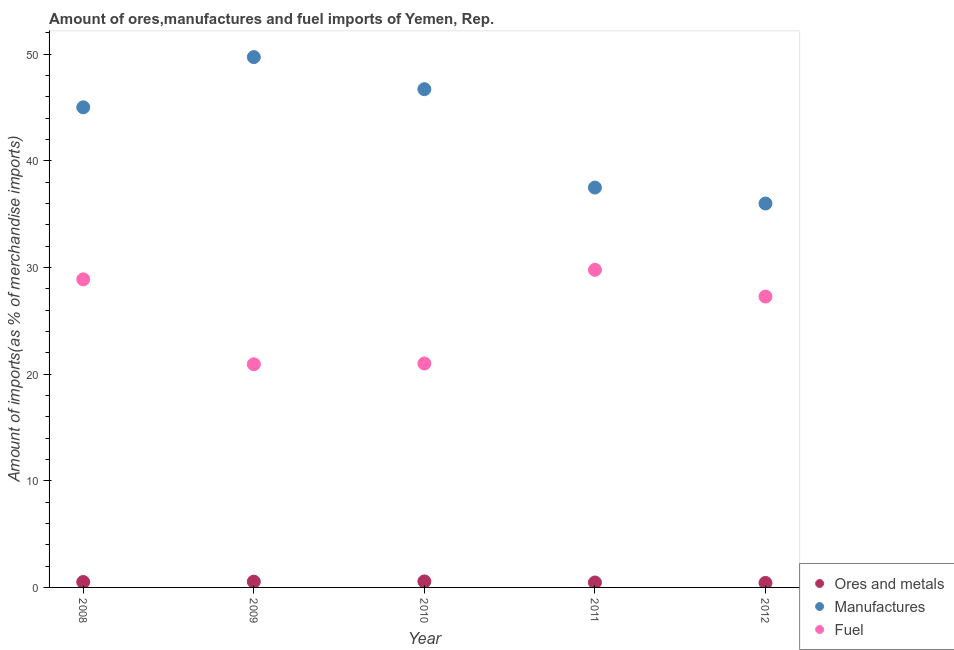Is the number of dotlines equal to the number of legend labels?
Offer a terse response. Yes. What is the percentage of fuel imports in 2008?
Ensure brevity in your answer.  28.89. Across all years, what is the maximum percentage of fuel imports?
Make the answer very short. 29.79. Across all years, what is the minimum percentage of fuel imports?
Offer a terse response. 20.93. In which year was the percentage of ores and metals imports maximum?
Your response must be concise. 2010. In which year was the percentage of manufactures imports minimum?
Your answer should be compact. 2012. What is the total percentage of manufactures imports in the graph?
Offer a very short reply. 214.99. What is the difference between the percentage of fuel imports in 2008 and that in 2010?
Your response must be concise. 7.89. What is the difference between the percentage of fuel imports in 2011 and the percentage of ores and metals imports in 2012?
Your answer should be compact. 29.36. What is the average percentage of manufactures imports per year?
Provide a succinct answer. 43. In the year 2010, what is the difference between the percentage of fuel imports and percentage of manufactures imports?
Provide a succinct answer. -25.73. What is the ratio of the percentage of manufactures imports in 2010 to that in 2011?
Offer a terse response. 1.25. Is the difference between the percentage of fuel imports in 2008 and 2012 greater than the difference between the percentage of ores and metals imports in 2008 and 2012?
Keep it short and to the point. Yes. What is the difference between the highest and the second highest percentage of manufactures imports?
Your response must be concise. 3.01. What is the difference between the highest and the lowest percentage of ores and metals imports?
Your answer should be compact. 0.14. In how many years, is the percentage of manufactures imports greater than the average percentage of manufactures imports taken over all years?
Your answer should be compact. 3. Is the sum of the percentage of ores and metals imports in 2010 and 2012 greater than the maximum percentage of fuel imports across all years?
Give a very brief answer. No. Is the percentage of manufactures imports strictly less than the percentage of ores and metals imports over the years?
Provide a short and direct response. No. How many dotlines are there?
Offer a very short reply. 3. What is the difference between two consecutive major ticks on the Y-axis?
Your answer should be very brief. 10. Does the graph contain any zero values?
Your answer should be very brief. No. Does the graph contain grids?
Offer a terse response. No. How are the legend labels stacked?
Offer a very short reply. Vertical. What is the title of the graph?
Offer a very short reply. Amount of ores,manufactures and fuel imports of Yemen, Rep. What is the label or title of the X-axis?
Keep it short and to the point. Year. What is the label or title of the Y-axis?
Provide a succinct answer. Amount of imports(as % of merchandise imports). What is the Amount of imports(as % of merchandise imports) of Ores and metals in 2008?
Provide a short and direct response. 0.51. What is the Amount of imports(as % of merchandise imports) of Manufactures in 2008?
Give a very brief answer. 45.03. What is the Amount of imports(as % of merchandise imports) in Fuel in 2008?
Offer a very short reply. 28.89. What is the Amount of imports(as % of merchandise imports) of Ores and metals in 2009?
Ensure brevity in your answer.  0.54. What is the Amount of imports(as % of merchandise imports) of Manufactures in 2009?
Provide a succinct answer. 49.73. What is the Amount of imports(as % of merchandise imports) of Fuel in 2009?
Make the answer very short. 20.93. What is the Amount of imports(as % of merchandise imports) of Ores and metals in 2010?
Give a very brief answer. 0.56. What is the Amount of imports(as % of merchandise imports) in Manufactures in 2010?
Make the answer very short. 46.73. What is the Amount of imports(as % of merchandise imports) in Fuel in 2010?
Provide a succinct answer. 21. What is the Amount of imports(as % of merchandise imports) of Ores and metals in 2011?
Make the answer very short. 0.46. What is the Amount of imports(as % of merchandise imports) in Manufactures in 2011?
Provide a short and direct response. 37.5. What is the Amount of imports(as % of merchandise imports) in Fuel in 2011?
Offer a very short reply. 29.79. What is the Amount of imports(as % of merchandise imports) of Ores and metals in 2012?
Your answer should be very brief. 0.42. What is the Amount of imports(as % of merchandise imports) of Manufactures in 2012?
Provide a succinct answer. 36. What is the Amount of imports(as % of merchandise imports) in Fuel in 2012?
Your answer should be compact. 27.28. Across all years, what is the maximum Amount of imports(as % of merchandise imports) in Ores and metals?
Offer a very short reply. 0.56. Across all years, what is the maximum Amount of imports(as % of merchandise imports) in Manufactures?
Offer a very short reply. 49.73. Across all years, what is the maximum Amount of imports(as % of merchandise imports) of Fuel?
Give a very brief answer. 29.79. Across all years, what is the minimum Amount of imports(as % of merchandise imports) of Ores and metals?
Ensure brevity in your answer.  0.42. Across all years, what is the minimum Amount of imports(as % of merchandise imports) of Manufactures?
Your response must be concise. 36. Across all years, what is the minimum Amount of imports(as % of merchandise imports) in Fuel?
Offer a very short reply. 20.93. What is the total Amount of imports(as % of merchandise imports) of Ores and metals in the graph?
Offer a very short reply. 2.5. What is the total Amount of imports(as % of merchandise imports) of Manufactures in the graph?
Make the answer very short. 214.99. What is the total Amount of imports(as % of merchandise imports) in Fuel in the graph?
Your answer should be compact. 127.88. What is the difference between the Amount of imports(as % of merchandise imports) in Ores and metals in 2008 and that in 2009?
Keep it short and to the point. -0.04. What is the difference between the Amount of imports(as % of merchandise imports) in Manufactures in 2008 and that in 2009?
Your answer should be very brief. -4.71. What is the difference between the Amount of imports(as % of merchandise imports) in Fuel in 2008 and that in 2009?
Give a very brief answer. 7.96. What is the difference between the Amount of imports(as % of merchandise imports) in Ores and metals in 2008 and that in 2010?
Ensure brevity in your answer.  -0.06. What is the difference between the Amount of imports(as % of merchandise imports) in Manufactures in 2008 and that in 2010?
Ensure brevity in your answer.  -1.7. What is the difference between the Amount of imports(as % of merchandise imports) of Fuel in 2008 and that in 2010?
Provide a succinct answer. 7.89. What is the difference between the Amount of imports(as % of merchandise imports) in Ores and metals in 2008 and that in 2011?
Offer a very short reply. 0.04. What is the difference between the Amount of imports(as % of merchandise imports) in Manufactures in 2008 and that in 2011?
Offer a very short reply. 7.53. What is the difference between the Amount of imports(as % of merchandise imports) in Fuel in 2008 and that in 2011?
Make the answer very short. -0.89. What is the difference between the Amount of imports(as % of merchandise imports) of Ores and metals in 2008 and that in 2012?
Ensure brevity in your answer.  0.08. What is the difference between the Amount of imports(as % of merchandise imports) of Manufactures in 2008 and that in 2012?
Make the answer very short. 9.02. What is the difference between the Amount of imports(as % of merchandise imports) of Fuel in 2008 and that in 2012?
Provide a short and direct response. 1.61. What is the difference between the Amount of imports(as % of merchandise imports) of Ores and metals in 2009 and that in 2010?
Offer a very short reply. -0.02. What is the difference between the Amount of imports(as % of merchandise imports) in Manufactures in 2009 and that in 2010?
Give a very brief answer. 3.01. What is the difference between the Amount of imports(as % of merchandise imports) in Fuel in 2009 and that in 2010?
Keep it short and to the point. -0.07. What is the difference between the Amount of imports(as % of merchandise imports) in Ores and metals in 2009 and that in 2011?
Offer a terse response. 0.08. What is the difference between the Amount of imports(as % of merchandise imports) in Manufactures in 2009 and that in 2011?
Keep it short and to the point. 12.23. What is the difference between the Amount of imports(as % of merchandise imports) in Fuel in 2009 and that in 2011?
Keep it short and to the point. -8.86. What is the difference between the Amount of imports(as % of merchandise imports) of Ores and metals in 2009 and that in 2012?
Offer a terse response. 0.12. What is the difference between the Amount of imports(as % of merchandise imports) of Manufactures in 2009 and that in 2012?
Provide a succinct answer. 13.73. What is the difference between the Amount of imports(as % of merchandise imports) in Fuel in 2009 and that in 2012?
Your answer should be compact. -6.35. What is the difference between the Amount of imports(as % of merchandise imports) in Ores and metals in 2010 and that in 2011?
Offer a very short reply. 0.1. What is the difference between the Amount of imports(as % of merchandise imports) of Manufactures in 2010 and that in 2011?
Your answer should be very brief. 9.23. What is the difference between the Amount of imports(as % of merchandise imports) in Fuel in 2010 and that in 2011?
Ensure brevity in your answer.  -8.79. What is the difference between the Amount of imports(as % of merchandise imports) in Ores and metals in 2010 and that in 2012?
Your response must be concise. 0.14. What is the difference between the Amount of imports(as % of merchandise imports) of Manufactures in 2010 and that in 2012?
Your response must be concise. 10.72. What is the difference between the Amount of imports(as % of merchandise imports) of Fuel in 2010 and that in 2012?
Keep it short and to the point. -6.28. What is the difference between the Amount of imports(as % of merchandise imports) in Ores and metals in 2011 and that in 2012?
Your answer should be compact. 0.04. What is the difference between the Amount of imports(as % of merchandise imports) in Manufactures in 2011 and that in 2012?
Your answer should be compact. 1.5. What is the difference between the Amount of imports(as % of merchandise imports) of Fuel in 2011 and that in 2012?
Provide a short and direct response. 2.51. What is the difference between the Amount of imports(as % of merchandise imports) in Ores and metals in 2008 and the Amount of imports(as % of merchandise imports) in Manufactures in 2009?
Offer a very short reply. -49.23. What is the difference between the Amount of imports(as % of merchandise imports) in Ores and metals in 2008 and the Amount of imports(as % of merchandise imports) in Fuel in 2009?
Ensure brevity in your answer.  -20.42. What is the difference between the Amount of imports(as % of merchandise imports) of Manufactures in 2008 and the Amount of imports(as % of merchandise imports) of Fuel in 2009?
Provide a succinct answer. 24.1. What is the difference between the Amount of imports(as % of merchandise imports) in Ores and metals in 2008 and the Amount of imports(as % of merchandise imports) in Manufactures in 2010?
Offer a terse response. -46.22. What is the difference between the Amount of imports(as % of merchandise imports) of Ores and metals in 2008 and the Amount of imports(as % of merchandise imports) of Fuel in 2010?
Your answer should be compact. -20.49. What is the difference between the Amount of imports(as % of merchandise imports) in Manufactures in 2008 and the Amount of imports(as % of merchandise imports) in Fuel in 2010?
Offer a very short reply. 24.02. What is the difference between the Amount of imports(as % of merchandise imports) of Ores and metals in 2008 and the Amount of imports(as % of merchandise imports) of Manufactures in 2011?
Ensure brevity in your answer.  -36.99. What is the difference between the Amount of imports(as % of merchandise imports) in Ores and metals in 2008 and the Amount of imports(as % of merchandise imports) in Fuel in 2011?
Offer a terse response. -29.28. What is the difference between the Amount of imports(as % of merchandise imports) in Manufactures in 2008 and the Amount of imports(as % of merchandise imports) in Fuel in 2011?
Your answer should be compact. 15.24. What is the difference between the Amount of imports(as % of merchandise imports) of Ores and metals in 2008 and the Amount of imports(as % of merchandise imports) of Manufactures in 2012?
Provide a short and direct response. -35.5. What is the difference between the Amount of imports(as % of merchandise imports) in Ores and metals in 2008 and the Amount of imports(as % of merchandise imports) in Fuel in 2012?
Your response must be concise. -26.77. What is the difference between the Amount of imports(as % of merchandise imports) in Manufactures in 2008 and the Amount of imports(as % of merchandise imports) in Fuel in 2012?
Your answer should be compact. 17.75. What is the difference between the Amount of imports(as % of merchandise imports) in Ores and metals in 2009 and the Amount of imports(as % of merchandise imports) in Manufactures in 2010?
Offer a terse response. -46.18. What is the difference between the Amount of imports(as % of merchandise imports) in Ores and metals in 2009 and the Amount of imports(as % of merchandise imports) in Fuel in 2010?
Keep it short and to the point. -20.46. What is the difference between the Amount of imports(as % of merchandise imports) of Manufactures in 2009 and the Amount of imports(as % of merchandise imports) of Fuel in 2010?
Offer a very short reply. 28.73. What is the difference between the Amount of imports(as % of merchandise imports) of Ores and metals in 2009 and the Amount of imports(as % of merchandise imports) of Manufactures in 2011?
Your answer should be very brief. -36.96. What is the difference between the Amount of imports(as % of merchandise imports) in Ores and metals in 2009 and the Amount of imports(as % of merchandise imports) in Fuel in 2011?
Provide a succinct answer. -29.24. What is the difference between the Amount of imports(as % of merchandise imports) in Manufactures in 2009 and the Amount of imports(as % of merchandise imports) in Fuel in 2011?
Provide a succinct answer. 19.95. What is the difference between the Amount of imports(as % of merchandise imports) of Ores and metals in 2009 and the Amount of imports(as % of merchandise imports) of Manufactures in 2012?
Ensure brevity in your answer.  -35.46. What is the difference between the Amount of imports(as % of merchandise imports) of Ores and metals in 2009 and the Amount of imports(as % of merchandise imports) of Fuel in 2012?
Ensure brevity in your answer.  -26.73. What is the difference between the Amount of imports(as % of merchandise imports) in Manufactures in 2009 and the Amount of imports(as % of merchandise imports) in Fuel in 2012?
Provide a succinct answer. 22.46. What is the difference between the Amount of imports(as % of merchandise imports) of Ores and metals in 2010 and the Amount of imports(as % of merchandise imports) of Manufactures in 2011?
Ensure brevity in your answer.  -36.94. What is the difference between the Amount of imports(as % of merchandise imports) of Ores and metals in 2010 and the Amount of imports(as % of merchandise imports) of Fuel in 2011?
Ensure brevity in your answer.  -29.22. What is the difference between the Amount of imports(as % of merchandise imports) in Manufactures in 2010 and the Amount of imports(as % of merchandise imports) in Fuel in 2011?
Provide a succinct answer. 16.94. What is the difference between the Amount of imports(as % of merchandise imports) in Ores and metals in 2010 and the Amount of imports(as % of merchandise imports) in Manufactures in 2012?
Make the answer very short. -35.44. What is the difference between the Amount of imports(as % of merchandise imports) in Ores and metals in 2010 and the Amount of imports(as % of merchandise imports) in Fuel in 2012?
Offer a terse response. -26.71. What is the difference between the Amount of imports(as % of merchandise imports) in Manufactures in 2010 and the Amount of imports(as % of merchandise imports) in Fuel in 2012?
Provide a short and direct response. 19.45. What is the difference between the Amount of imports(as % of merchandise imports) of Ores and metals in 2011 and the Amount of imports(as % of merchandise imports) of Manufactures in 2012?
Your answer should be compact. -35.54. What is the difference between the Amount of imports(as % of merchandise imports) of Ores and metals in 2011 and the Amount of imports(as % of merchandise imports) of Fuel in 2012?
Keep it short and to the point. -26.81. What is the difference between the Amount of imports(as % of merchandise imports) in Manufactures in 2011 and the Amount of imports(as % of merchandise imports) in Fuel in 2012?
Your answer should be very brief. 10.22. What is the average Amount of imports(as % of merchandise imports) in Ores and metals per year?
Provide a short and direct response. 0.5. What is the average Amount of imports(as % of merchandise imports) in Manufactures per year?
Make the answer very short. 43. What is the average Amount of imports(as % of merchandise imports) of Fuel per year?
Provide a succinct answer. 25.58. In the year 2008, what is the difference between the Amount of imports(as % of merchandise imports) of Ores and metals and Amount of imports(as % of merchandise imports) of Manufactures?
Keep it short and to the point. -44.52. In the year 2008, what is the difference between the Amount of imports(as % of merchandise imports) of Ores and metals and Amount of imports(as % of merchandise imports) of Fuel?
Your answer should be very brief. -28.38. In the year 2008, what is the difference between the Amount of imports(as % of merchandise imports) of Manufactures and Amount of imports(as % of merchandise imports) of Fuel?
Your answer should be compact. 16.13. In the year 2009, what is the difference between the Amount of imports(as % of merchandise imports) in Ores and metals and Amount of imports(as % of merchandise imports) in Manufactures?
Provide a succinct answer. -49.19. In the year 2009, what is the difference between the Amount of imports(as % of merchandise imports) in Ores and metals and Amount of imports(as % of merchandise imports) in Fuel?
Make the answer very short. -20.39. In the year 2009, what is the difference between the Amount of imports(as % of merchandise imports) in Manufactures and Amount of imports(as % of merchandise imports) in Fuel?
Ensure brevity in your answer.  28.8. In the year 2010, what is the difference between the Amount of imports(as % of merchandise imports) of Ores and metals and Amount of imports(as % of merchandise imports) of Manufactures?
Offer a terse response. -46.16. In the year 2010, what is the difference between the Amount of imports(as % of merchandise imports) of Ores and metals and Amount of imports(as % of merchandise imports) of Fuel?
Make the answer very short. -20.44. In the year 2010, what is the difference between the Amount of imports(as % of merchandise imports) of Manufactures and Amount of imports(as % of merchandise imports) of Fuel?
Make the answer very short. 25.73. In the year 2011, what is the difference between the Amount of imports(as % of merchandise imports) in Ores and metals and Amount of imports(as % of merchandise imports) in Manufactures?
Provide a short and direct response. -37.04. In the year 2011, what is the difference between the Amount of imports(as % of merchandise imports) of Ores and metals and Amount of imports(as % of merchandise imports) of Fuel?
Offer a terse response. -29.32. In the year 2011, what is the difference between the Amount of imports(as % of merchandise imports) of Manufactures and Amount of imports(as % of merchandise imports) of Fuel?
Give a very brief answer. 7.71. In the year 2012, what is the difference between the Amount of imports(as % of merchandise imports) of Ores and metals and Amount of imports(as % of merchandise imports) of Manufactures?
Keep it short and to the point. -35.58. In the year 2012, what is the difference between the Amount of imports(as % of merchandise imports) in Ores and metals and Amount of imports(as % of merchandise imports) in Fuel?
Provide a succinct answer. -26.86. In the year 2012, what is the difference between the Amount of imports(as % of merchandise imports) in Manufactures and Amount of imports(as % of merchandise imports) in Fuel?
Provide a short and direct response. 8.73. What is the ratio of the Amount of imports(as % of merchandise imports) of Ores and metals in 2008 to that in 2009?
Offer a very short reply. 0.93. What is the ratio of the Amount of imports(as % of merchandise imports) in Manufactures in 2008 to that in 2009?
Give a very brief answer. 0.91. What is the ratio of the Amount of imports(as % of merchandise imports) of Fuel in 2008 to that in 2009?
Your response must be concise. 1.38. What is the ratio of the Amount of imports(as % of merchandise imports) of Ores and metals in 2008 to that in 2010?
Provide a succinct answer. 0.9. What is the ratio of the Amount of imports(as % of merchandise imports) in Manufactures in 2008 to that in 2010?
Provide a short and direct response. 0.96. What is the ratio of the Amount of imports(as % of merchandise imports) of Fuel in 2008 to that in 2010?
Keep it short and to the point. 1.38. What is the ratio of the Amount of imports(as % of merchandise imports) of Ores and metals in 2008 to that in 2011?
Offer a terse response. 1.09. What is the ratio of the Amount of imports(as % of merchandise imports) in Manufactures in 2008 to that in 2011?
Your answer should be very brief. 1.2. What is the ratio of the Amount of imports(as % of merchandise imports) of Ores and metals in 2008 to that in 2012?
Your answer should be compact. 1.2. What is the ratio of the Amount of imports(as % of merchandise imports) in Manufactures in 2008 to that in 2012?
Offer a terse response. 1.25. What is the ratio of the Amount of imports(as % of merchandise imports) in Fuel in 2008 to that in 2012?
Keep it short and to the point. 1.06. What is the ratio of the Amount of imports(as % of merchandise imports) in Ores and metals in 2009 to that in 2010?
Your answer should be very brief. 0.96. What is the ratio of the Amount of imports(as % of merchandise imports) of Manufactures in 2009 to that in 2010?
Keep it short and to the point. 1.06. What is the ratio of the Amount of imports(as % of merchandise imports) in Fuel in 2009 to that in 2010?
Your answer should be compact. 1. What is the ratio of the Amount of imports(as % of merchandise imports) of Ores and metals in 2009 to that in 2011?
Give a very brief answer. 1.17. What is the ratio of the Amount of imports(as % of merchandise imports) in Manufactures in 2009 to that in 2011?
Offer a terse response. 1.33. What is the ratio of the Amount of imports(as % of merchandise imports) in Fuel in 2009 to that in 2011?
Provide a short and direct response. 0.7. What is the ratio of the Amount of imports(as % of merchandise imports) in Ores and metals in 2009 to that in 2012?
Provide a succinct answer. 1.29. What is the ratio of the Amount of imports(as % of merchandise imports) of Manufactures in 2009 to that in 2012?
Make the answer very short. 1.38. What is the ratio of the Amount of imports(as % of merchandise imports) of Fuel in 2009 to that in 2012?
Your answer should be very brief. 0.77. What is the ratio of the Amount of imports(as % of merchandise imports) of Ores and metals in 2010 to that in 2011?
Provide a succinct answer. 1.22. What is the ratio of the Amount of imports(as % of merchandise imports) of Manufactures in 2010 to that in 2011?
Provide a short and direct response. 1.25. What is the ratio of the Amount of imports(as % of merchandise imports) of Fuel in 2010 to that in 2011?
Your answer should be very brief. 0.71. What is the ratio of the Amount of imports(as % of merchandise imports) of Ores and metals in 2010 to that in 2012?
Offer a terse response. 1.34. What is the ratio of the Amount of imports(as % of merchandise imports) of Manufactures in 2010 to that in 2012?
Offer a terse response. 1.3. What is the ratio of the Amount of imports(as % of merchandise imports) in Fuel in 2010 to that in 2012?
Offer a very short reply. 0.77. What is the ratio of the Amount of imports(as % of merchandise imports) in Ores and metals in 2011 to that in 2012?
Your response must be concise. 1.1. What is the ratio of the Amount of imports(as % of merchandise imports) of Manufactures in 2011 to that in 2012?
Your answer should be compact. 1.04. What is the ratio of the Amount of imports(as % of merchandise imports) in Fuel in 2011 to that in 2012?
Offer a terse response. 1.09. What is the difference between the highest and the second highest Amount of imports(as % of merchandise imports) in Ores and metals?
Offer a terse response. 0.02. What is the difference between the highest and the second highest Amount of imports(as % of merchandise imports) of Manufactures?
Your answer should be compact. 3.01. What is the difference between the highest and the second highest Amount of imports(as % of merchandise imports) of Fuel?
Your answer should be compact. 0.89. What is the difference between the highest and the lowest Amount of imports(as % of merchandise imports) of Ores and metals?
Your answer should be compact. 0.14. What is the difference between the highest and the lowest Amount of imports(as % of merchandise imports) of Manufactures?
Give a very brief answer. 13.73. What is the difference between the highest and the lowest Amount of imports(as % of merchandise imports) in Fuel?
Ensure brevity in your answer.  8.86. 